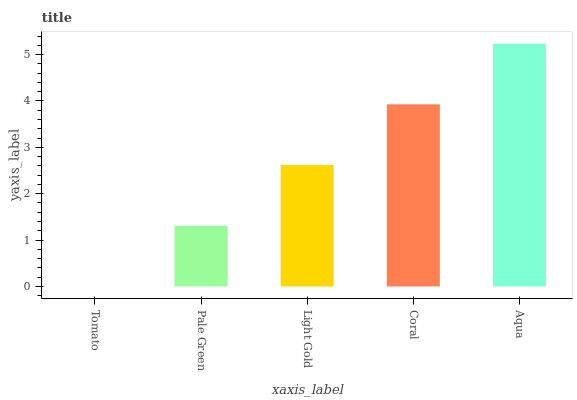Is Pale Green the minimum?
Answer yes or no. No. Is Pale Green the maximum?
Answer yes or no. No. Is Pale Green greater than Tomato?
Answer yes or no. Yes. Is Tomato less than Pale Green?
Answer yes or no. Yes. Is Tomato greater than Pale Green?
Answer yes or no. No. Is Pale Green less than Tomato?
Answer yes or no. No. Is Light Gold the high median?
Answer yes or no. Yes. Is Light Gold the low median?
Answer yes or no. Yes. Is Aqua the high median?
Answer yes or no. No. Is Pale Green the low median?
Answer yes or no. No. 